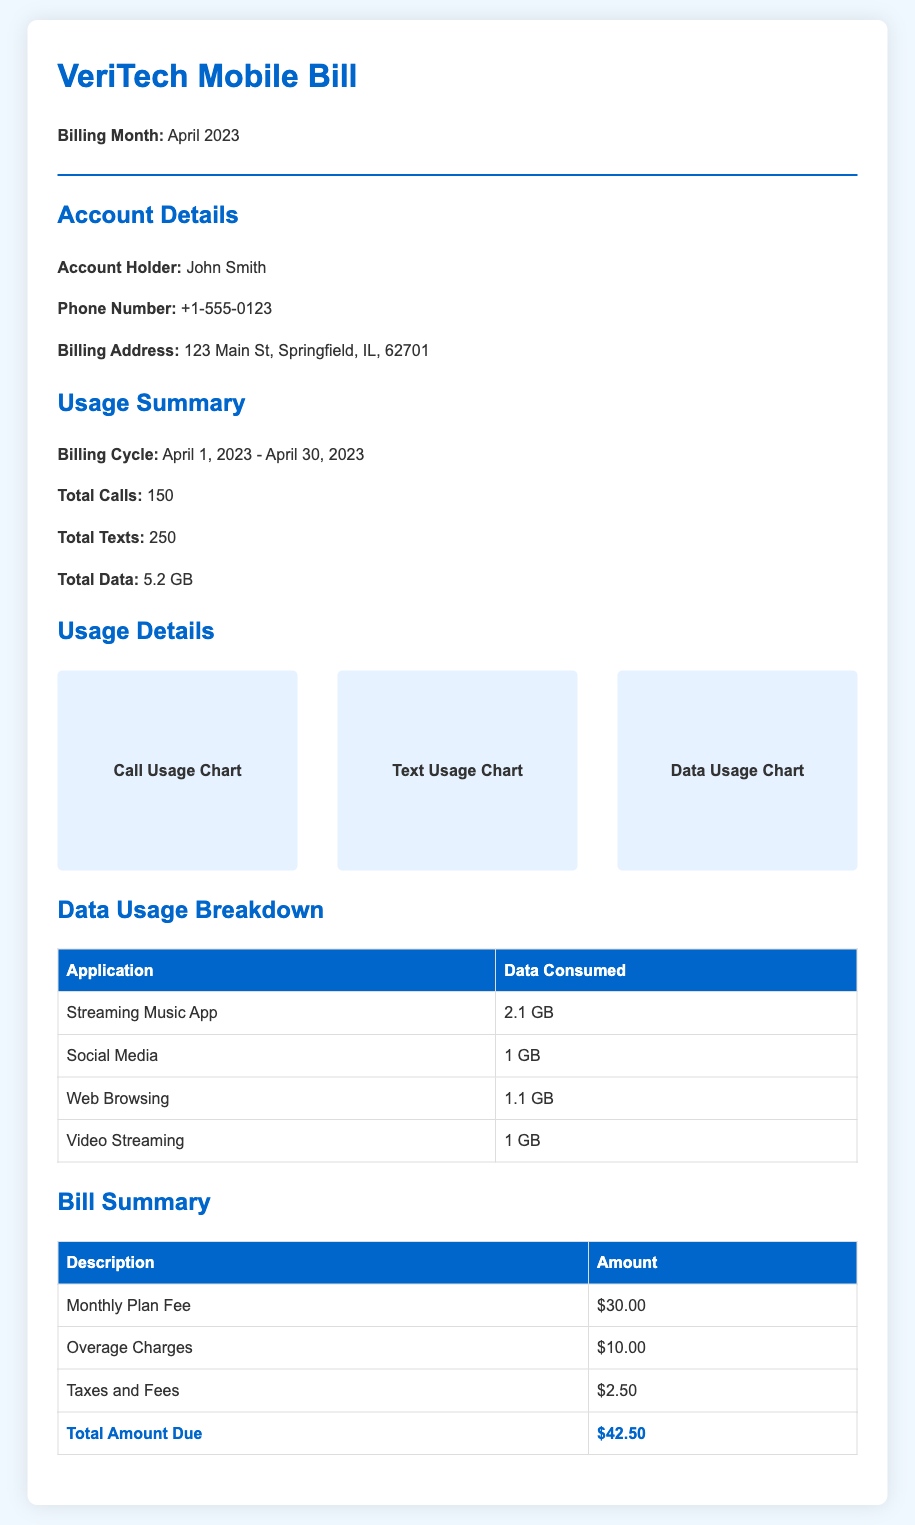What is the billing month? The billing month is clearly stated in the header of the document as "April 2023."
Answer: April 2023 How many total calls were made? The total number of calls made is listed in the Usage Summary section, which shows "Total Calls: 150."
Answer: 150 What is the total data used? The total data usage is mentioned in the Usage Summary as "Total Data: 5.2 GB."
Answer: 5.2 GB What is the name of the account holder? The account holder's name is provided in the Account Details section as "John Smith."
Answer: John Smith How much is the total amount due? The total amount due is found in the Bill Summary section listed as "Total Amount Due: $42.50."
Answer: $42.50 Which application consumed the most data? The application that consumed the most data is "Streaming Music App" with "2.1 GB" in the Data Usage Breakdown table.
Answer: Streaming Music App What is stated under "Taxes and Fees"? The amount for "Taxes and Fees" is clearly shown in the Bill Summary table.
Answer: $2.50 What is the billing address? The billing address is provided in the Account Details section and includes a street, city, state, and zip code.
Answer: 123 Main St, Springfield, IL, 62701 How many total texts were sent? The document details the total number of texts sent in the Usage Summary.
Answer: 250 